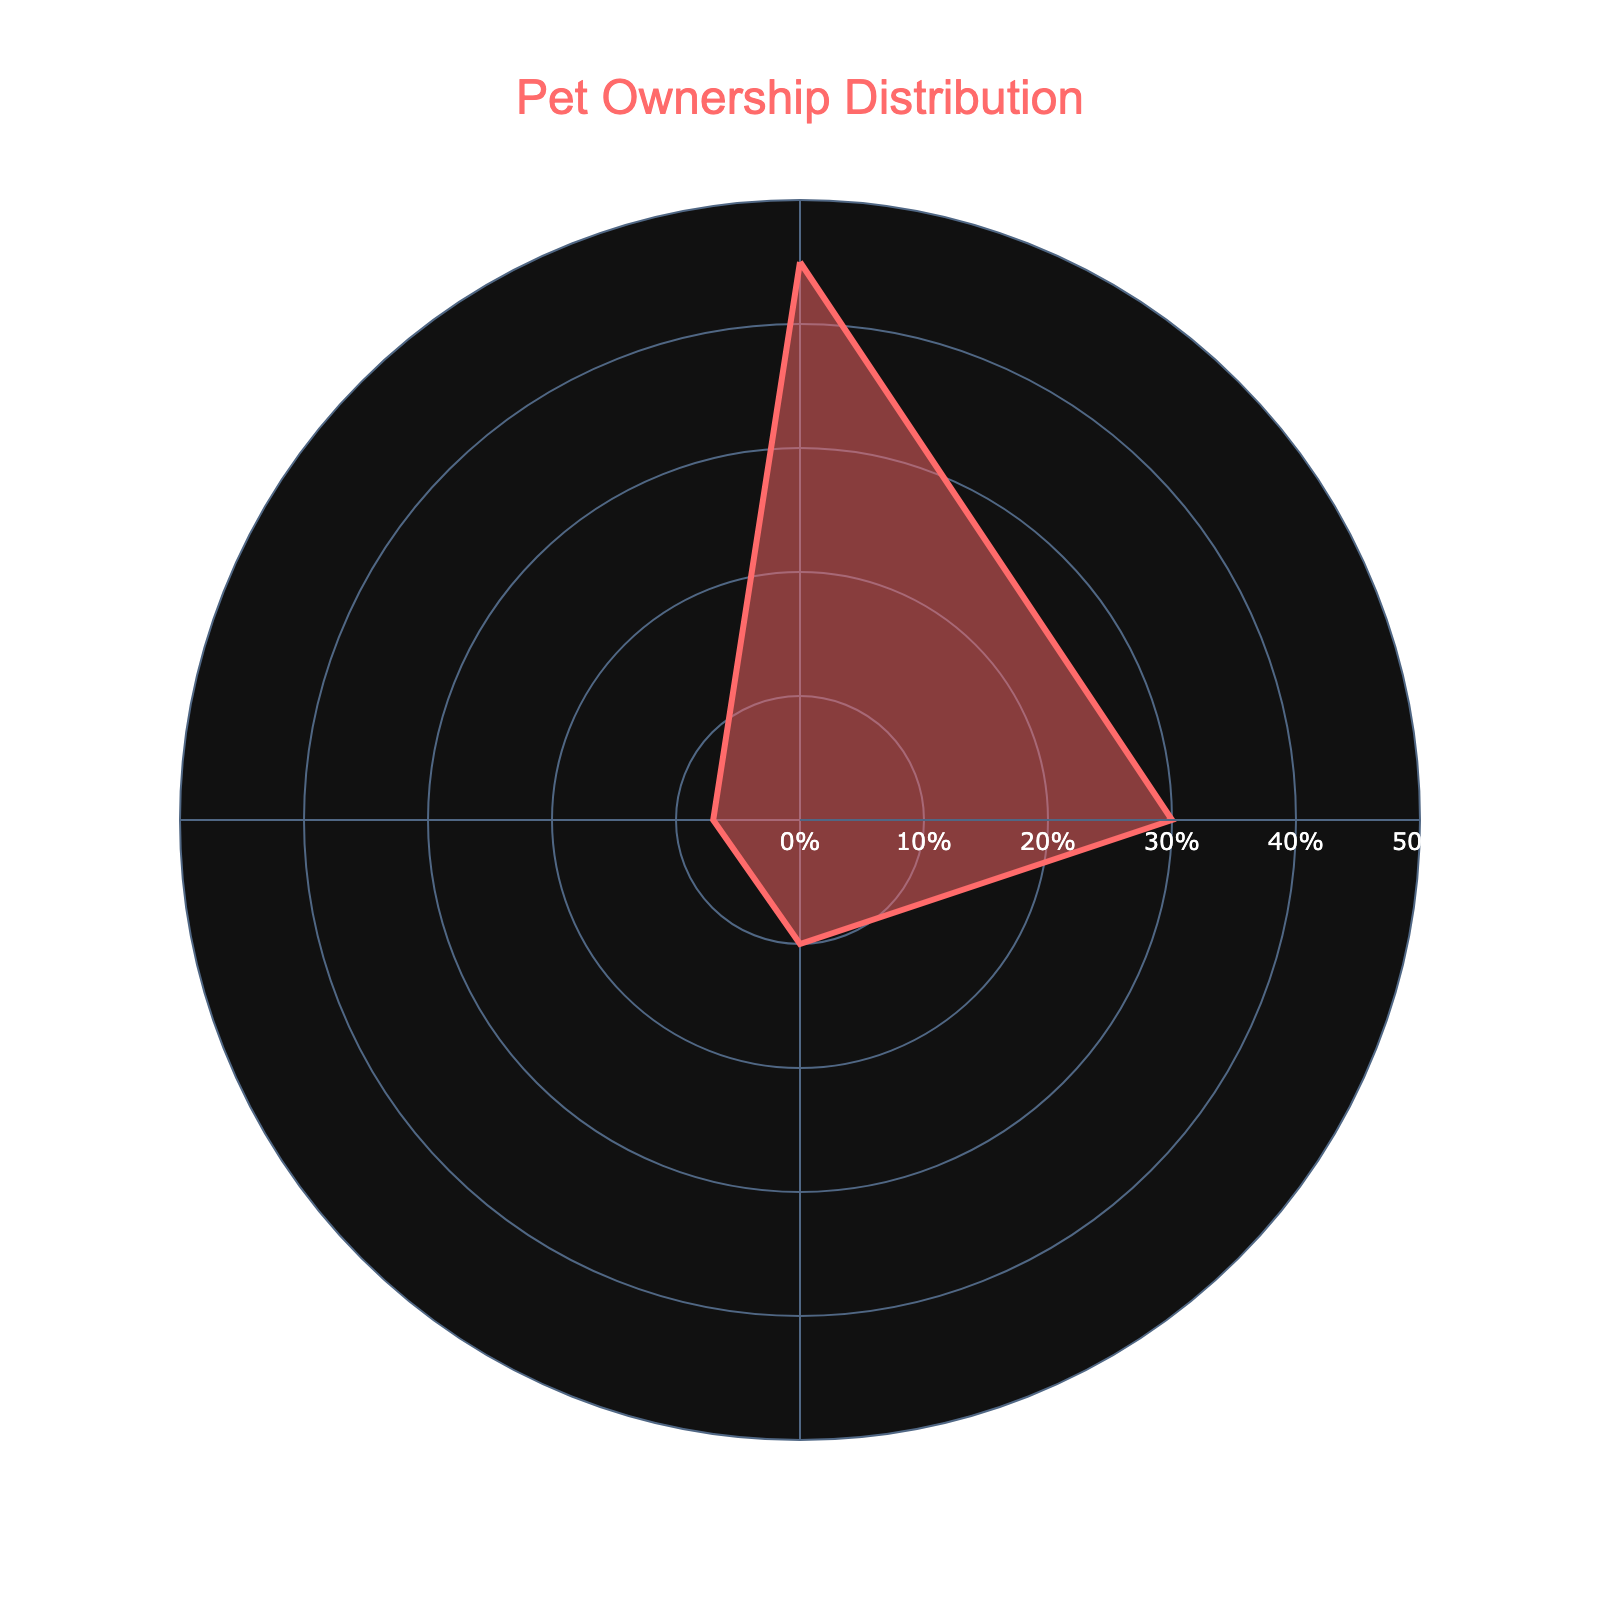What is the title of the figure? The title is located at the top of the figure. It describes what the chart is about.
Answer: Pet Ownership Distribution What percentage of pet owners have birds? The slice labeled "Birds" indicates the percentage in the radial axis.
Answer: 10% How many percentage points more dog owners are there compared to cat owners? Subtract the percentage of cat owners from the percentage of dog owners: 45% - 30% = 15%.
Answer: 15% Which type of pet has the smallest percentage of owners? The type of pet with the smallest percentage is the one with the shortest slice length on the radial axis.
Answer: Fish Rank the types of pets in order of ownership percentage from highest to lowest. Compare the segment lengths from largest to smallest as follows: Dogs (45%), Cats (30%), Birds (10%), Fish (7%).
Answer: Dogs, Cats, Birds, Fish What is the combined percentage of ownership for birds and fish? Add the percentages of birds and fish: 10% + 7% = 17%.
Answer: 17% Which two types of pets have the most similar ownership percentages? The two types of pets with the percentages closest to each other are Birds (10%) and Fish (7%) as the difference is 3 percentage points.
Answer: Birds and Fish Is there any type of pet owned by more than 40% of the population? Check if any segment extends beyond 40% on the radial axis. Dogs have an ownership percentage of 45%, which is greater than 40%.
Answer: Yes, Dogs Approximately what fraction of the pet owners have cats? Convert the percentage of cat owners into a fraction: 30% is approximately 3/10 or 0.3.
Answer: 3/10 In which direction are the type of pets arranged around the chart? Observe the angular arrangement of the types of pets around the circle; they are arranged in a clockwise direction.
Answer: Clockwise 